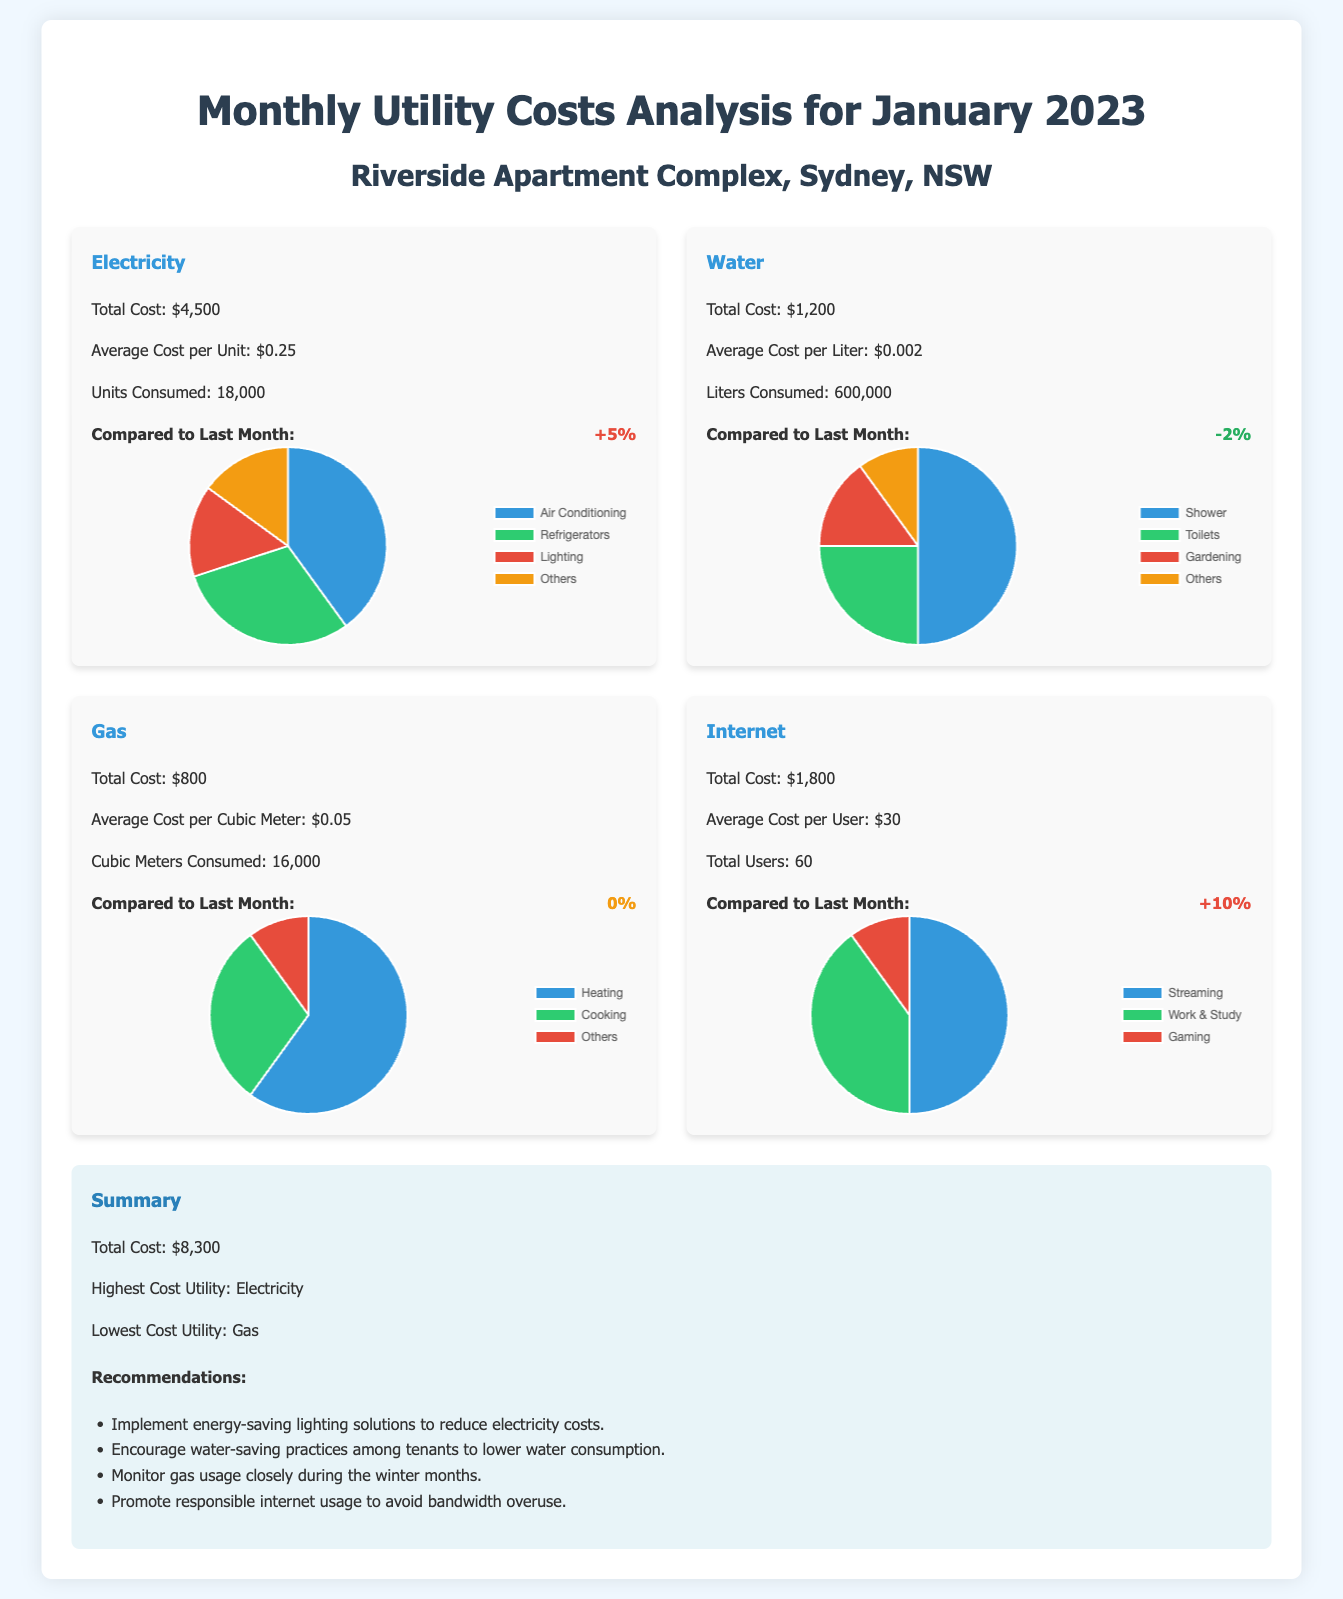What is the total cost of electricity? The total cost of electricity is specified in the document as $4,500.
Answer: $4,500 What is the average cost per user for internet? The average cost per user for internet is stated as $30.
Answer: $30 Which utility has the highest total cost? The document identifies electricity as the utility with the highest total cost.
Answer: Electricity What percentage increase did electricity costs show compared to last month? The document highlights that electricity costs increased by 5% compared to the previous month.
Answer: 5% How many liters of water were consumed? The total liters of water consumed is provided as 600,000.
Answer: 600,000 What recommendation is given to reduce electricity costs? One of the recommendations provided is to implement energy-saving lighting solutions.
Answer: Implement energy-saving lighting solutions What is the total cost of all utilities combined? The total cost of all utilities combined is mentioned as $8,300.
Answer: $8,300 How much did gas consumption cost in January 2023? The cost for gas consumption in January 2023 is noted as $800.
Answer: $800 What percentage decrease did water costs show compared to last month? The document states that water costs decreased by 2% from last month.
Answer: 2% What is the total number of internet users? The document specifies that there are a total of 60 internet users.
Answer: 60 